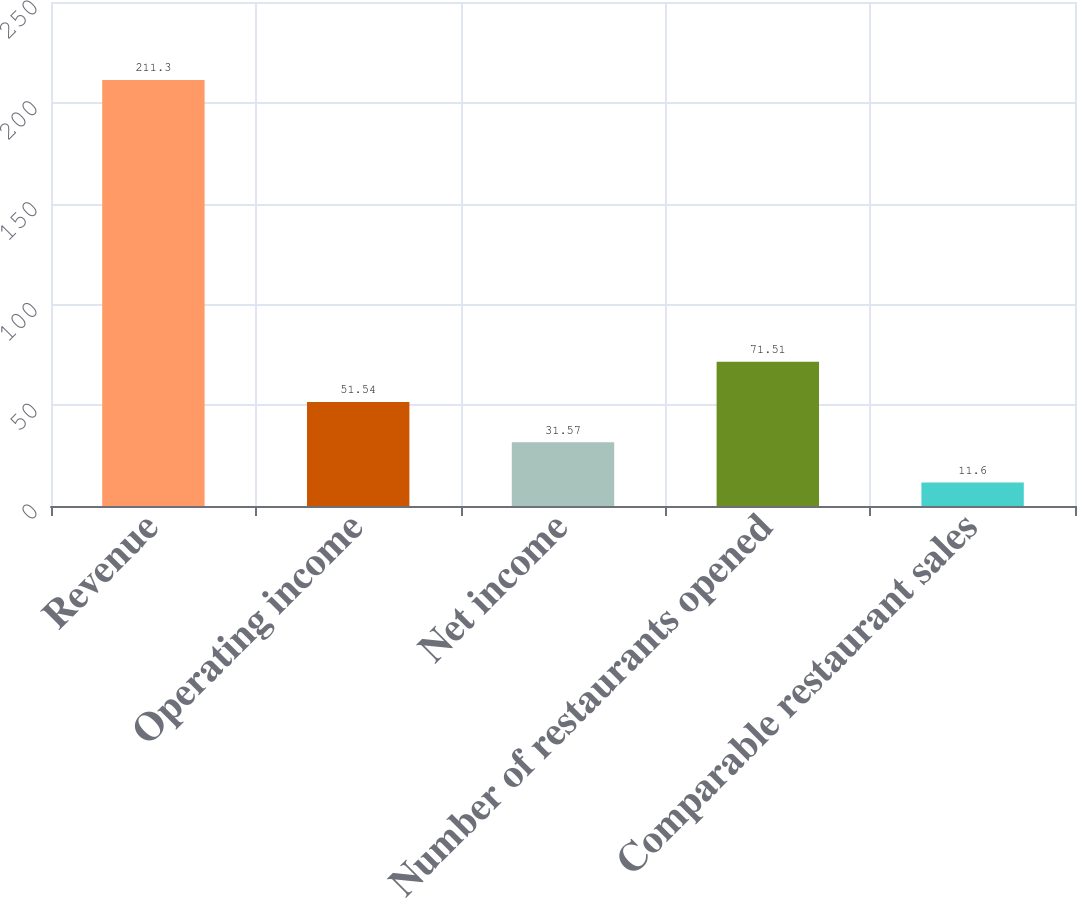<chart> <loc_0><loc_0><loc_500><loc_500><bar_chart><fcel>Revenue<fcel>Operating income<fcel>Net income<fcel>Number of restaurants opened<fcel>Comparable restaurant sales<nl><fcel>211.3<fcel>51.54<fcel>31.57<fcel>71.51<fcel>11.6<nl></chart> 